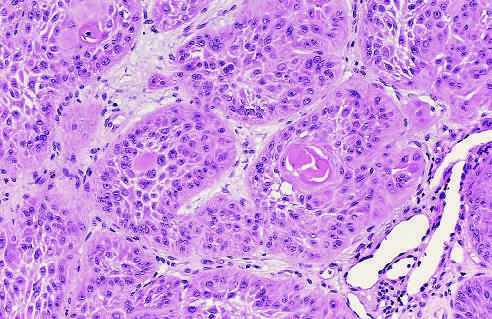how are the tumor cells strikingly similar to normal squamous epithelial cells?
Answer the question using a single word or phrase. With intercellular bridges and nests of keratin (arrow) 